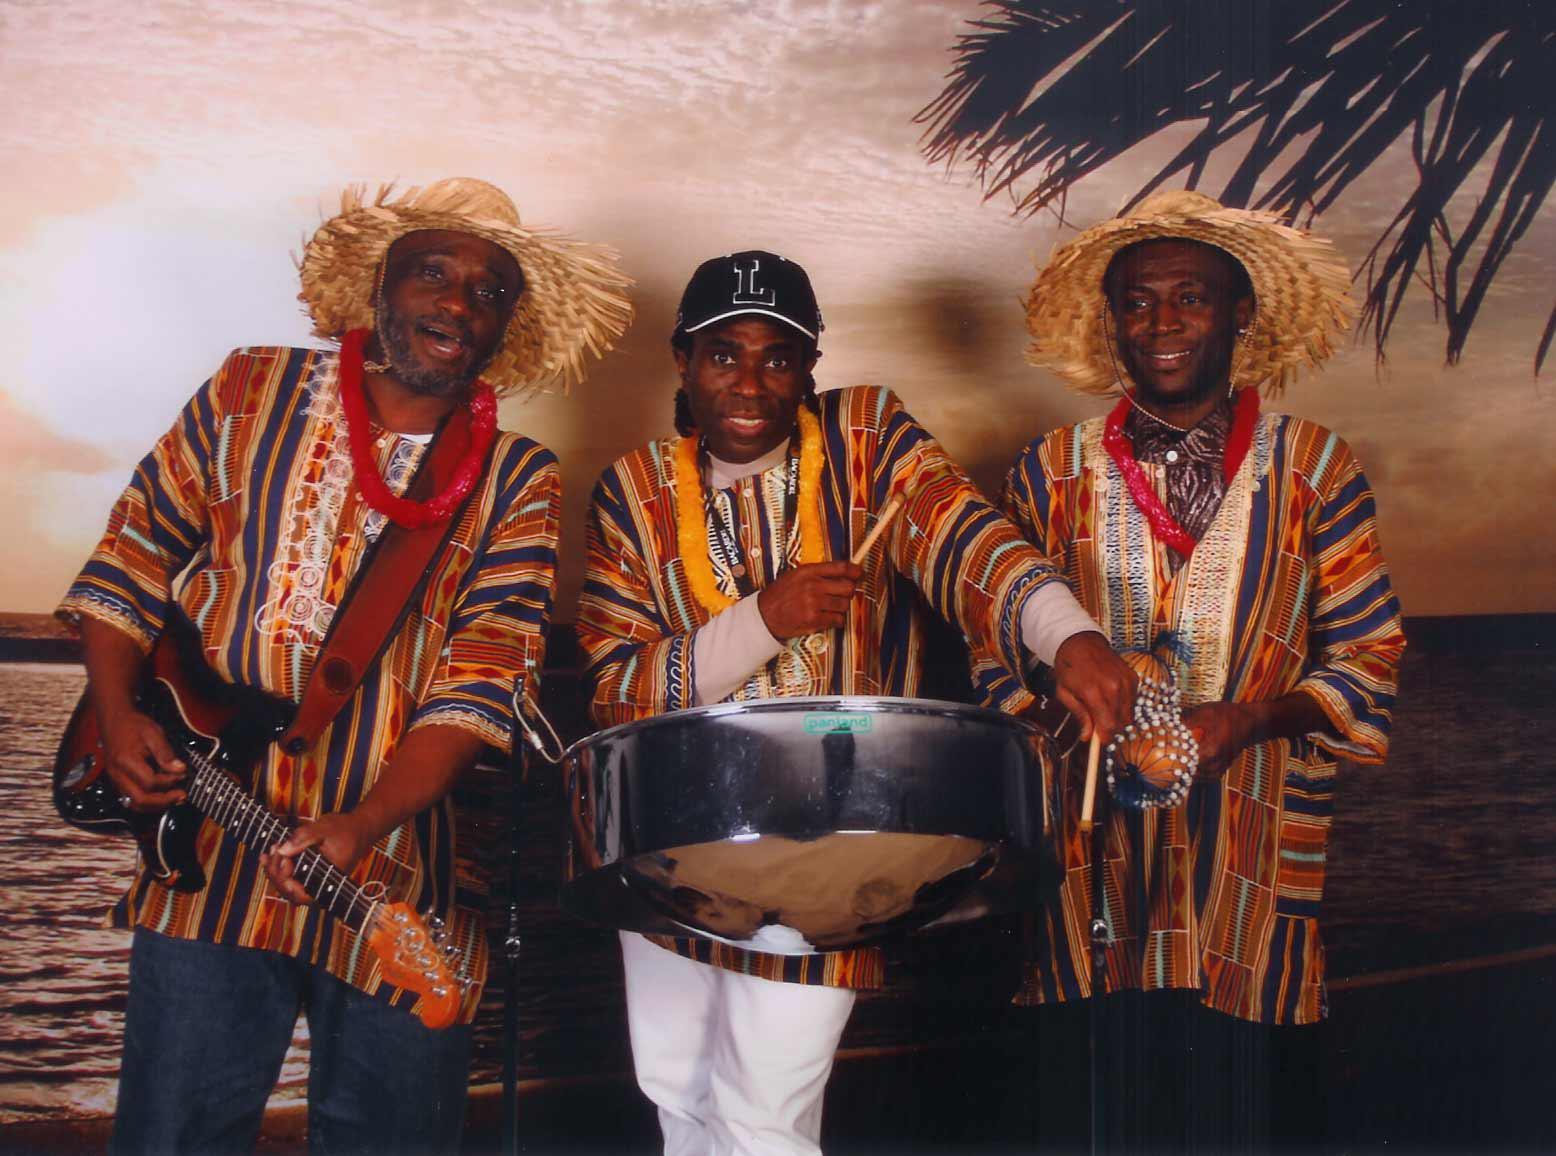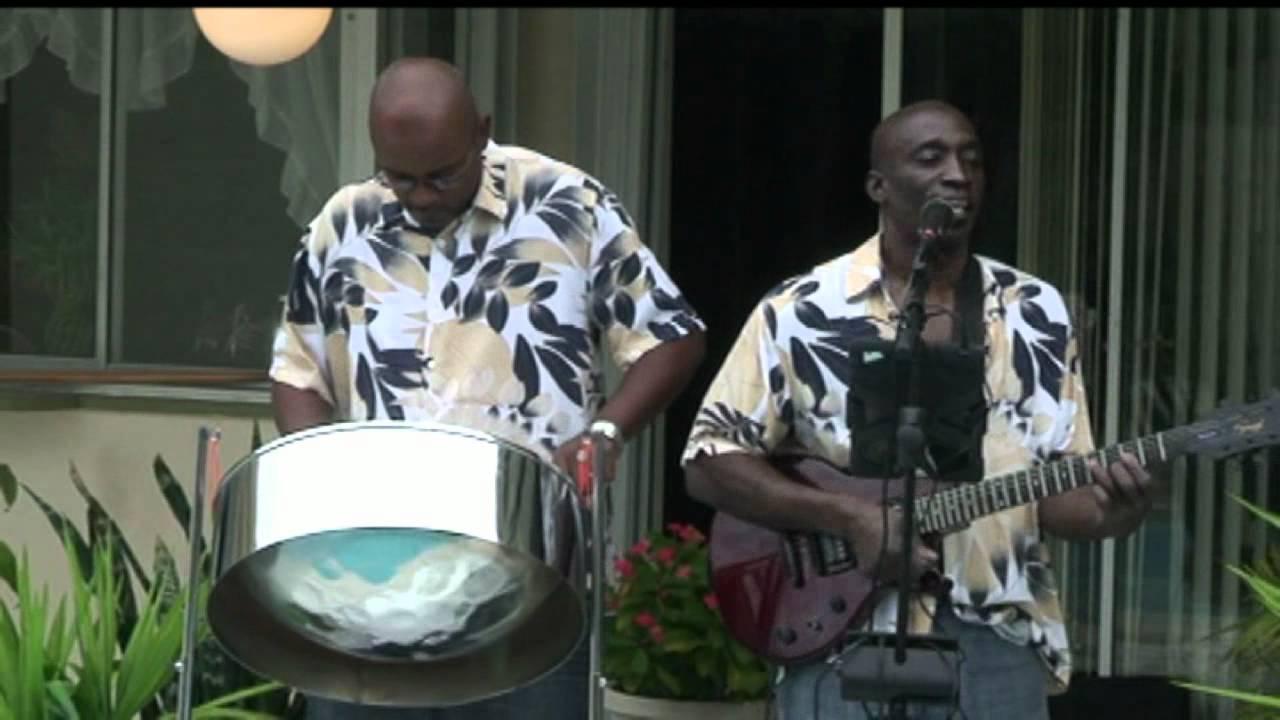The first image is the image on the left, the second image is the image on the right. Evaluate the accuracy of this statement regarding the images: "One drummer is wearing a floral print shirt.". Is it true? Answer yes or no. Yes. The first image is the image on the left, the second image is the image on the right. Given the left and right images, does the statement "There are three men standing next to each-other in the image on the left." hold true? Answer yes or no. Yes. 